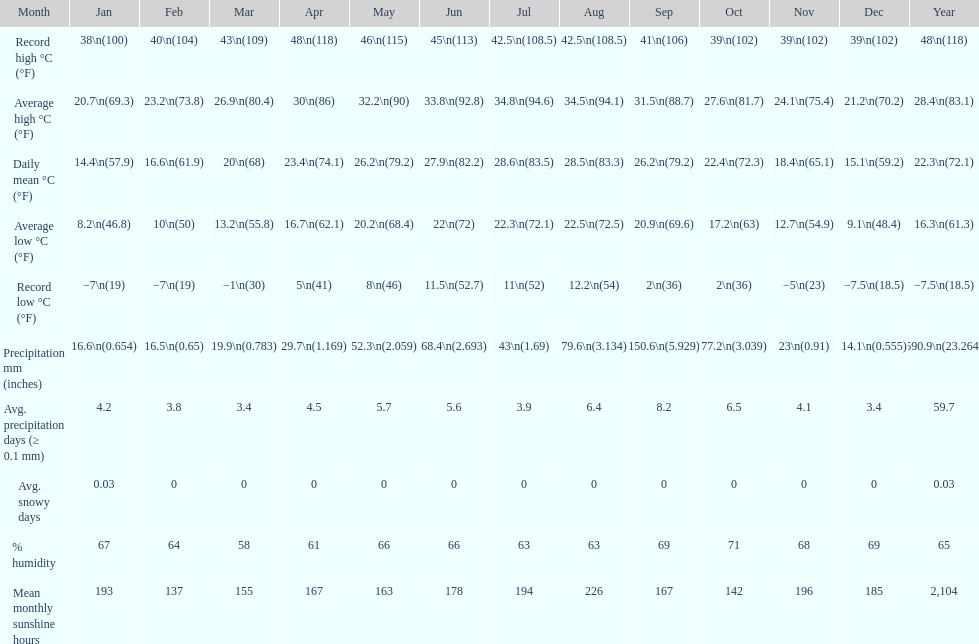Which month had the most sunny days? August. 